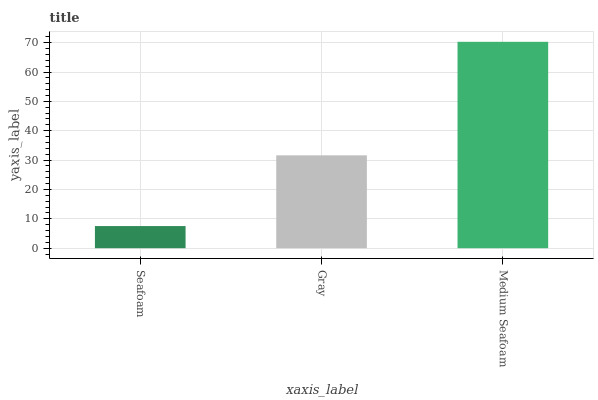Is Seafoam the minimum?
Answer yes or no. Yes. Is Medium Seafoam the maximum?
Answer yes or no. Yes. Is Gray the minimum?
Answer yes or no. No. Is Gray the maximum?
Answer yes or no. No. Is Gray greater than Seafoam?
Answer yes or no. Yes. Is Seafoam less than Gray?
Answer yes or no. Yes. Is Seafoam greater than Gray?
Answer yes or no. No. Is Gray less than Seafoam?
Answer yes or no. No. Is Gray the high median?
Answer yes or no. Yes. Is Gray the low median?
Answer yes or no. Yes. Is Seafoam the high median?
Answer yes or no. No. Is Seafoam the low median?
Answer yes or no. No. 